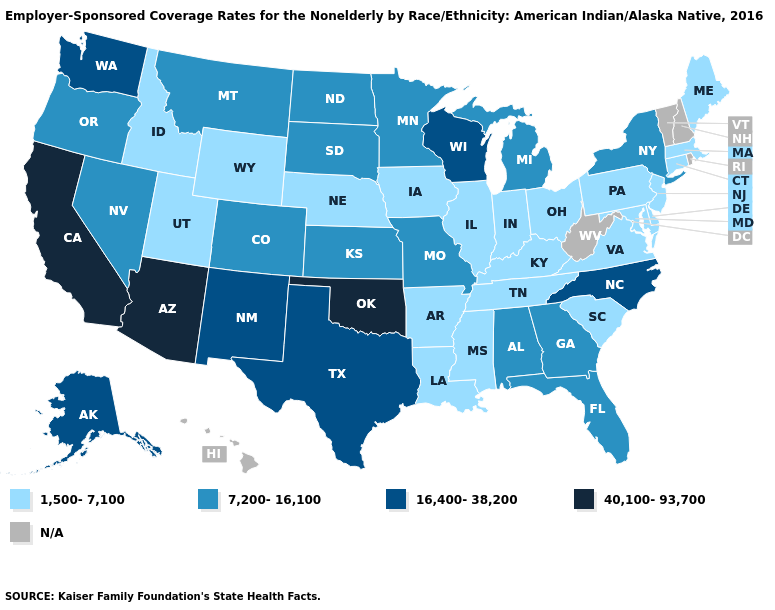Which states have the lowest value in the USA?
Short answer required. Arkansas, Connecticut, Delaware, Idaho, Illinois, Indiana, Iowa, Kentucky, Louisiana, Maine, Maryland, Massachusetts, Mississippi, Nebraska, New Jersey, Ohio, Pennsylvania, South Carolina, Tennessee, Utah, Virginia, Wyoming. What is the value of Oregon?
Keep it brief. 7,200-16,100. What is the value of Iowa?
Quick response, please. 1,500-7,100. Which states have the lowest value in the USA?
Keep it brief. Arkansas, Connecticut, Delaware, Idaho, Illinois, Indiana, Iowa, Kentucky, Louisiana, Maine, Maryland, Massachusetts, Mississippi, Nebraska, New Jersey, Ohio, Pennsylvania, South Carolina, Tennessee, Utah, Virginia, Wyoming. Does Kentucky have the highest value in the South?
Short answer required. No. What is the value of California?
Short answer required. 40,100-93,700. Name the states that have a value in the range 7,200-16,100?
Be succinct. Alabama, Colorado, Florida, Georgia, Kansas, Michigan, Minnesota, Missouri, Montana, Nevada, New York, North Dakota, Oregon, South Dakota. Name the states that have a value in the range 1,500-7,100?
Quick response, please. Arkansas, Connecticut, Delaware, Idaho, Illinois, Indiana, Iowa, Kentucky, Louisiana, Maine, Maryland, Massachusetts, Mississippi, Nebraska, New Jersey, Ohio, Pennsylvania, South Carolina, Tennessee, Utah, Virginia, Wyoming. What is the lowest value in the Northeast?
Quick response, please. 1,500-7,100. Among the states that border Arizona , does Colorado have the lowest value?
Write a very short answer. No. Among the states that border Oklahoma , does New Mexico have the highest value?
Quick response, please. Yes. Among the states that border Connecticut , which have the lowest value?
Short answer required. Massachusetts. Does Wyoming have the lowest value in the West?
Quick response, please. Yes. Does the first symbol in the legend represent the smallest category?
Short answer required. Yes. 